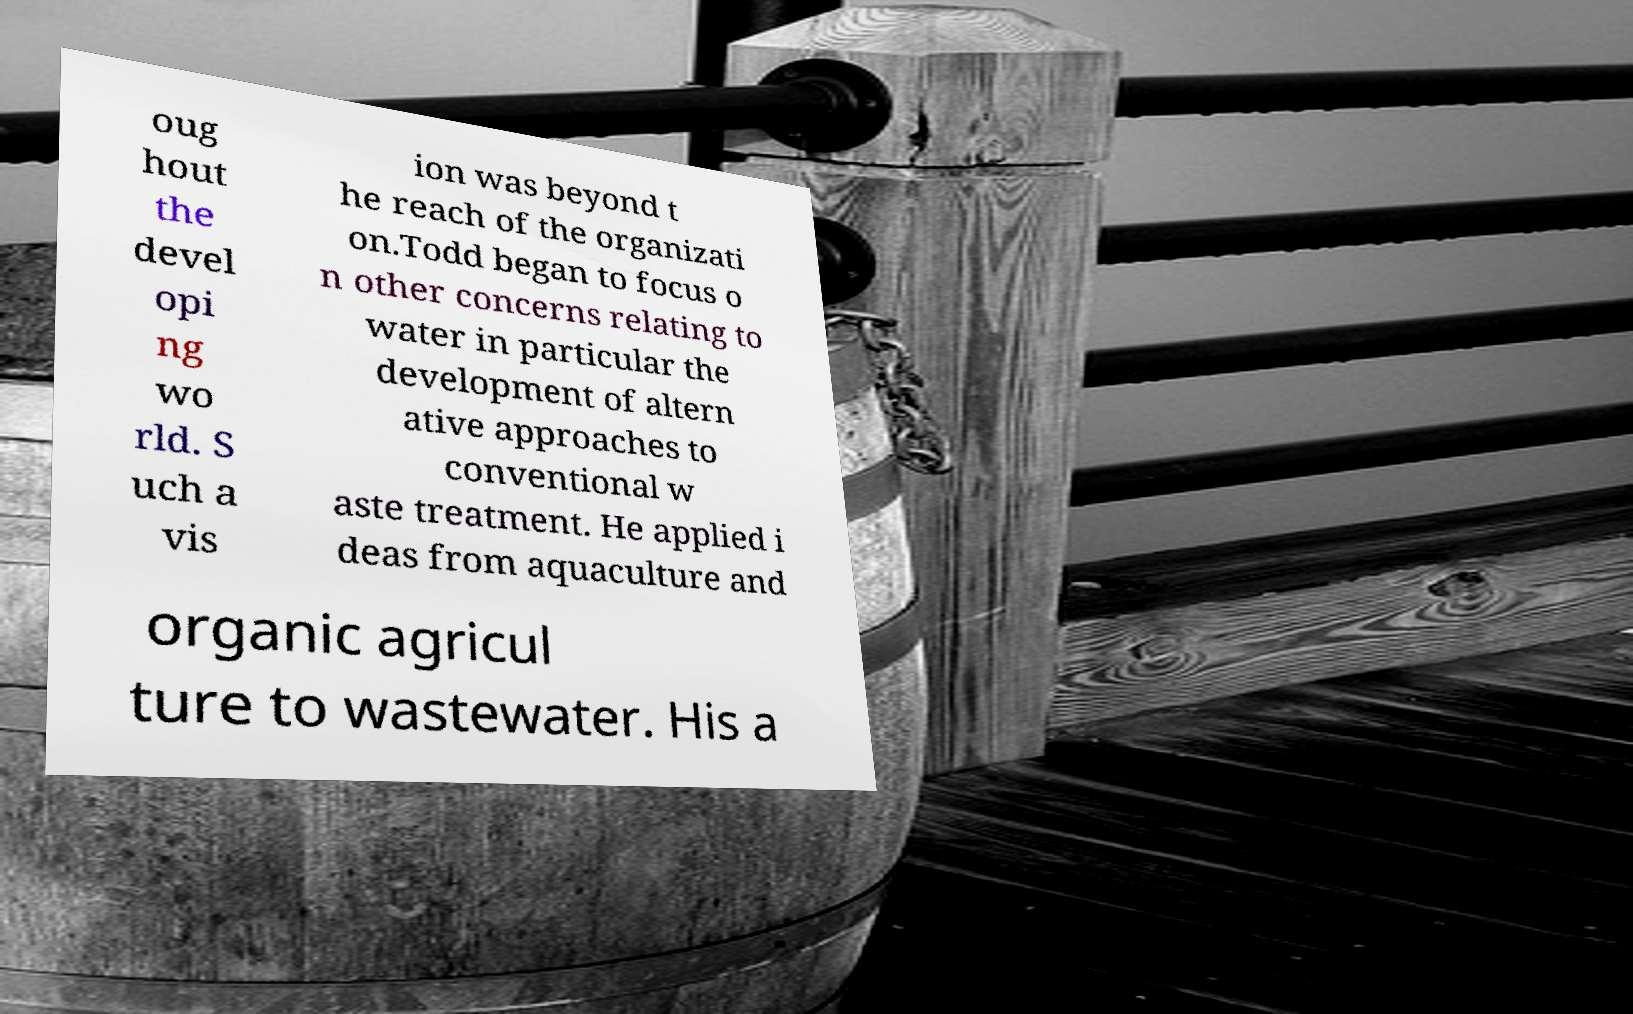Can you read and provide the text displayed in the image?This photo seems to have some interesting text. Can you extract and type it out for me? oug hout the devel opi ng wo rld. S uch a vis ion was beyond t he reach of the organizati on.Todd began to focus o n other concerns relating to water in particular the development of altern ative approaches to conventional w aste treatment. He applied i deas from aquaculture and organic agricul ture to wastewater. His a 